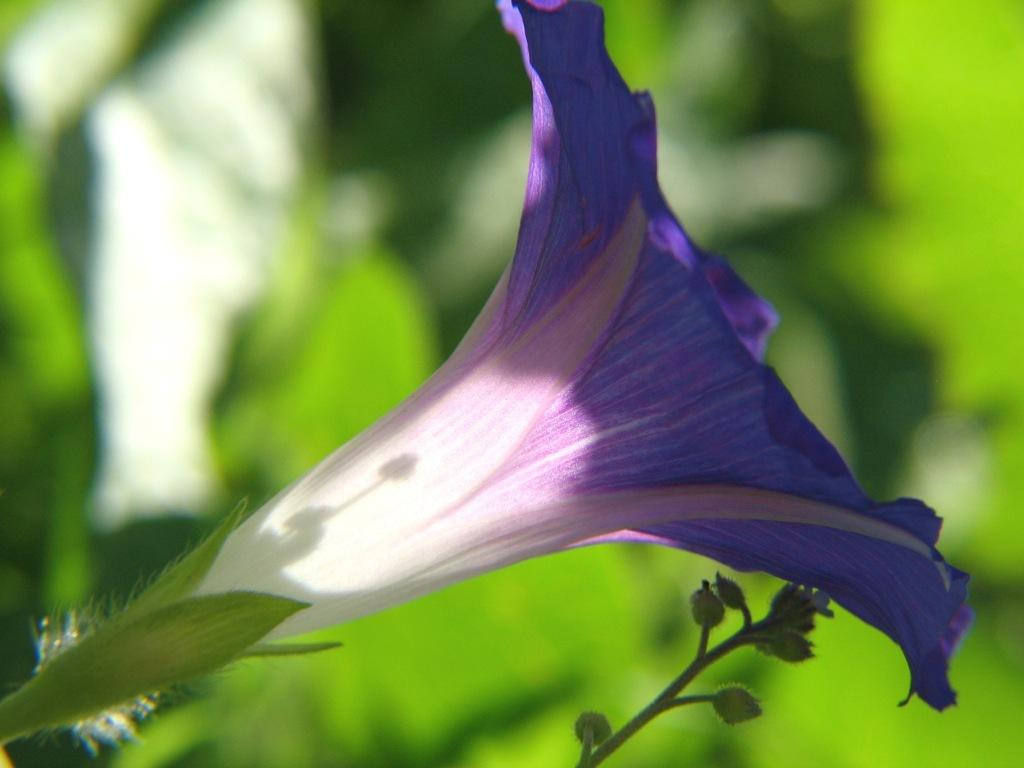What is the main subject of the image? There is a flower in the image. Are there any other plants visible in the image? Yes, there are plants in the image. Can you describe the setting where the image might have been taken? The image might have been taken in a garden. How many chairs can be seen supporting the flower in the image? There are no chairs present in the image, and the flower is not being supported by any chairs. 